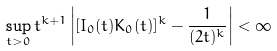Convert formula to latex. <formula><loc_0><loc_0><loc_500><loc_500>\sup _ { t > 0 } t ^ { k + 1 } \left | [ I _ { 0 } ( t ) K _ { 0 } ( t ) ] ^ { k } - \frac { 1 } { ( 2 t ) ^ { k } } \right | < \infty</formula> 